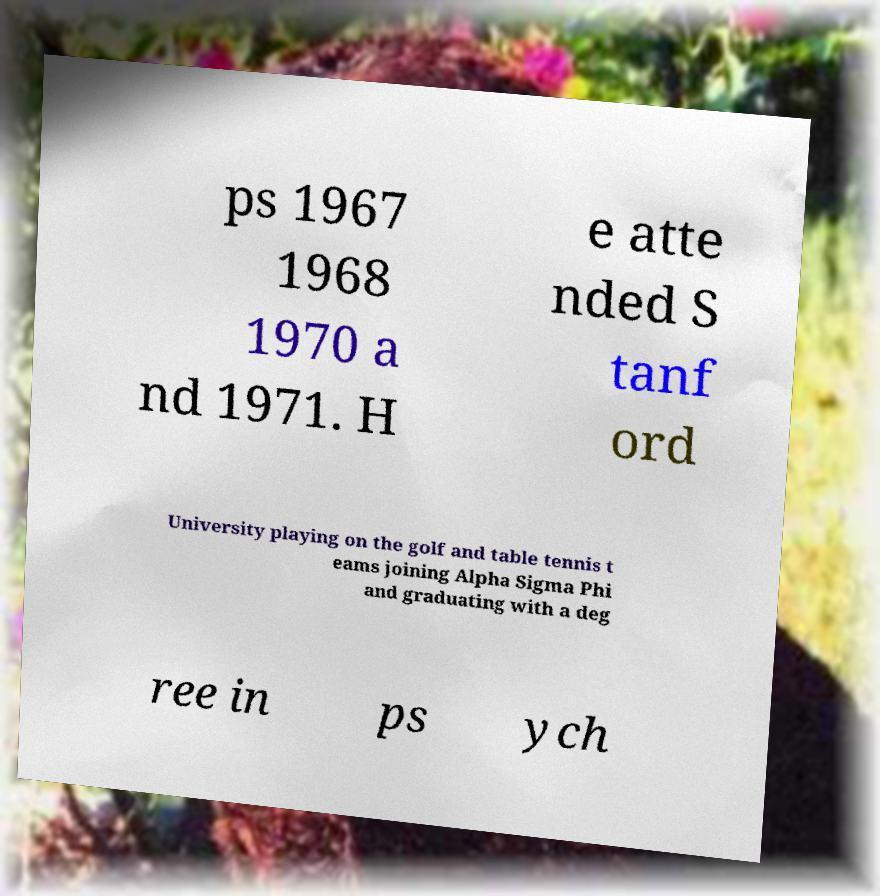There's text embedded in this image that I need extracted. Can you transcribe it verbatim? ps 1967 1968 1970 a nd 1971. H e atte nded S tanf ord University playing on the golf and table tennis t eams joining Alpha Sigma Phi and graduating with a deg ree in ps ych 